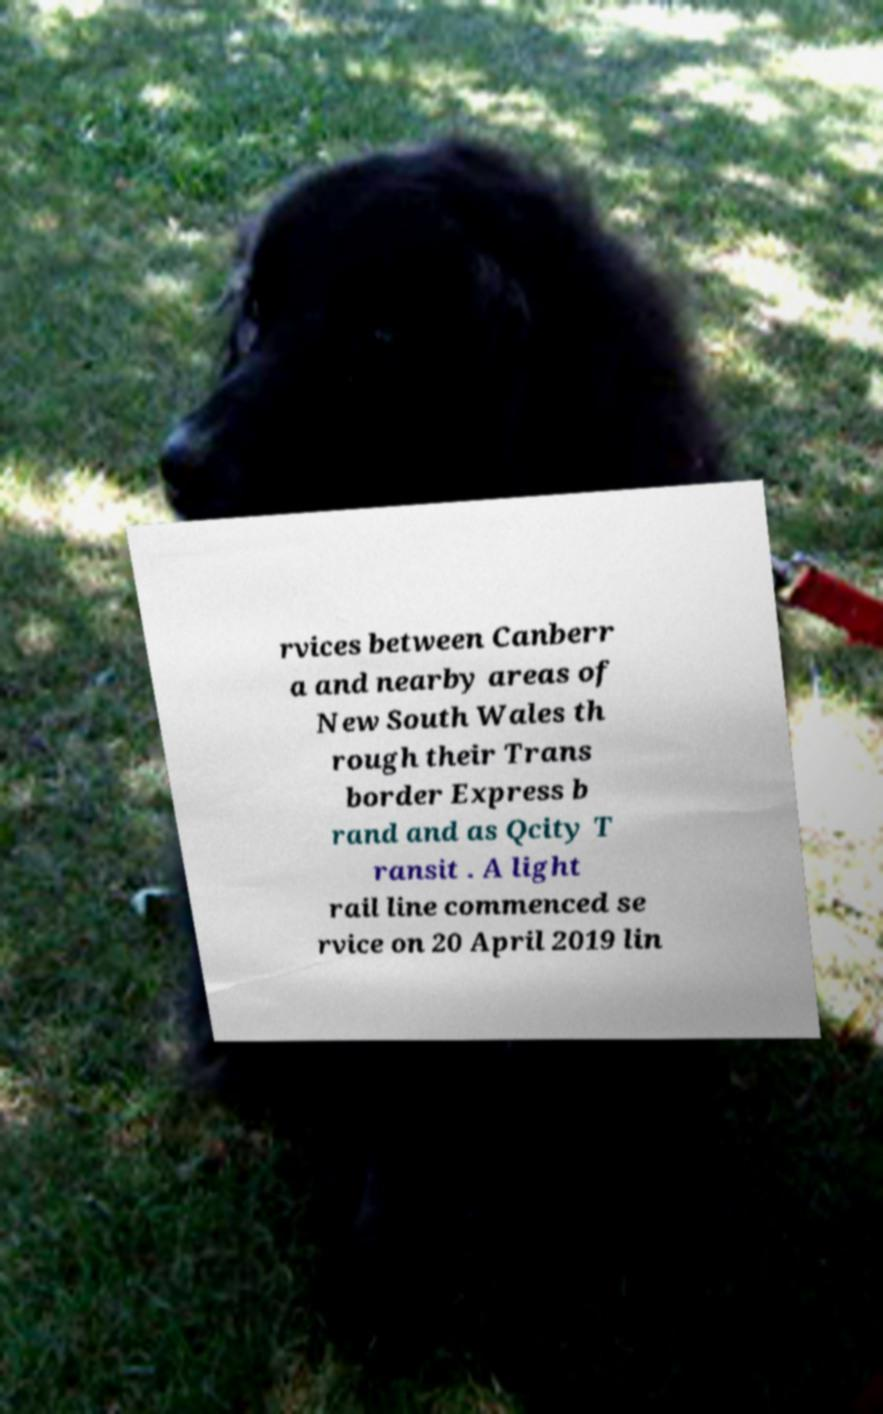I need the written content from this picture converted into text. Can you do that? rvices between Canberr a and nearby areas of New South Wales th rough their Trans border Express b rand and as Qcity T ransit . A light rail line commenced se rvice on 20 April 2019 lin 